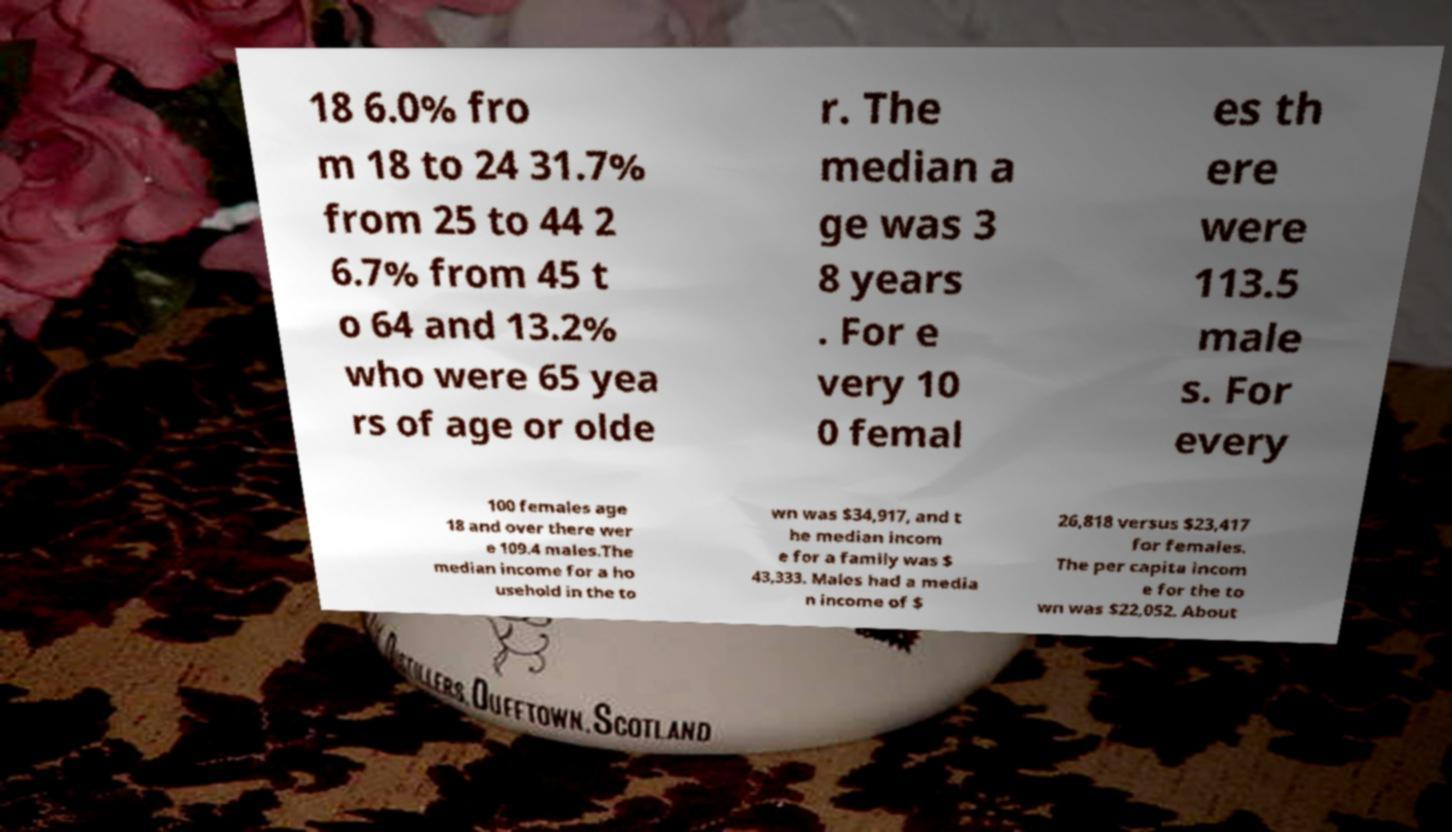Please identify and transcribe the text found in this image. 18 6.0% fro m 18 to 24 31.7% from 25 to 44 2 6.7% from 45 t o 64 and 13.2% who were 65 yea rs of age or olde r. The median a ge was 3 8 years . For e very 10 0 femal es th ere were 113.5 male s. For every 100 females age 18 and over there wer e 109.4 males.The median income for a ho usehold in the to wn was $34,917, and t he median incom e for a family was $ 43,333. Males had a media n income of $ 26,818 versus $23,417 for females. The per capita incom e for the to wn was $22,052. About 